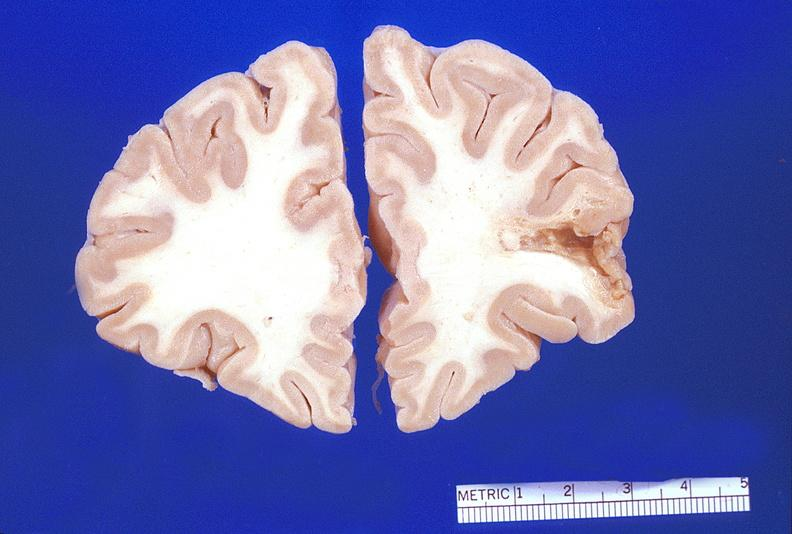does this image show brain, encephalomalacia?
Answer the question using a single word or phrase. Yes 